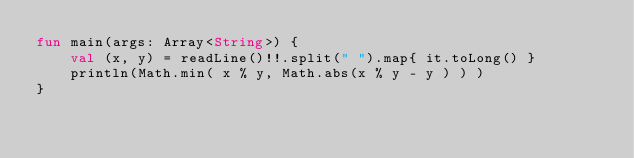Convert code to text. <code><loc_0><loc_0><loc_500><loc_500><_Kotlin_>fun main(args: Array<String>) {
    val (x, y) = readLine()!!.split(" ").map{ it.toLong() }
    println(Math.min( x % y, Math.abs(x % y - y ) ) )
}
</code> 